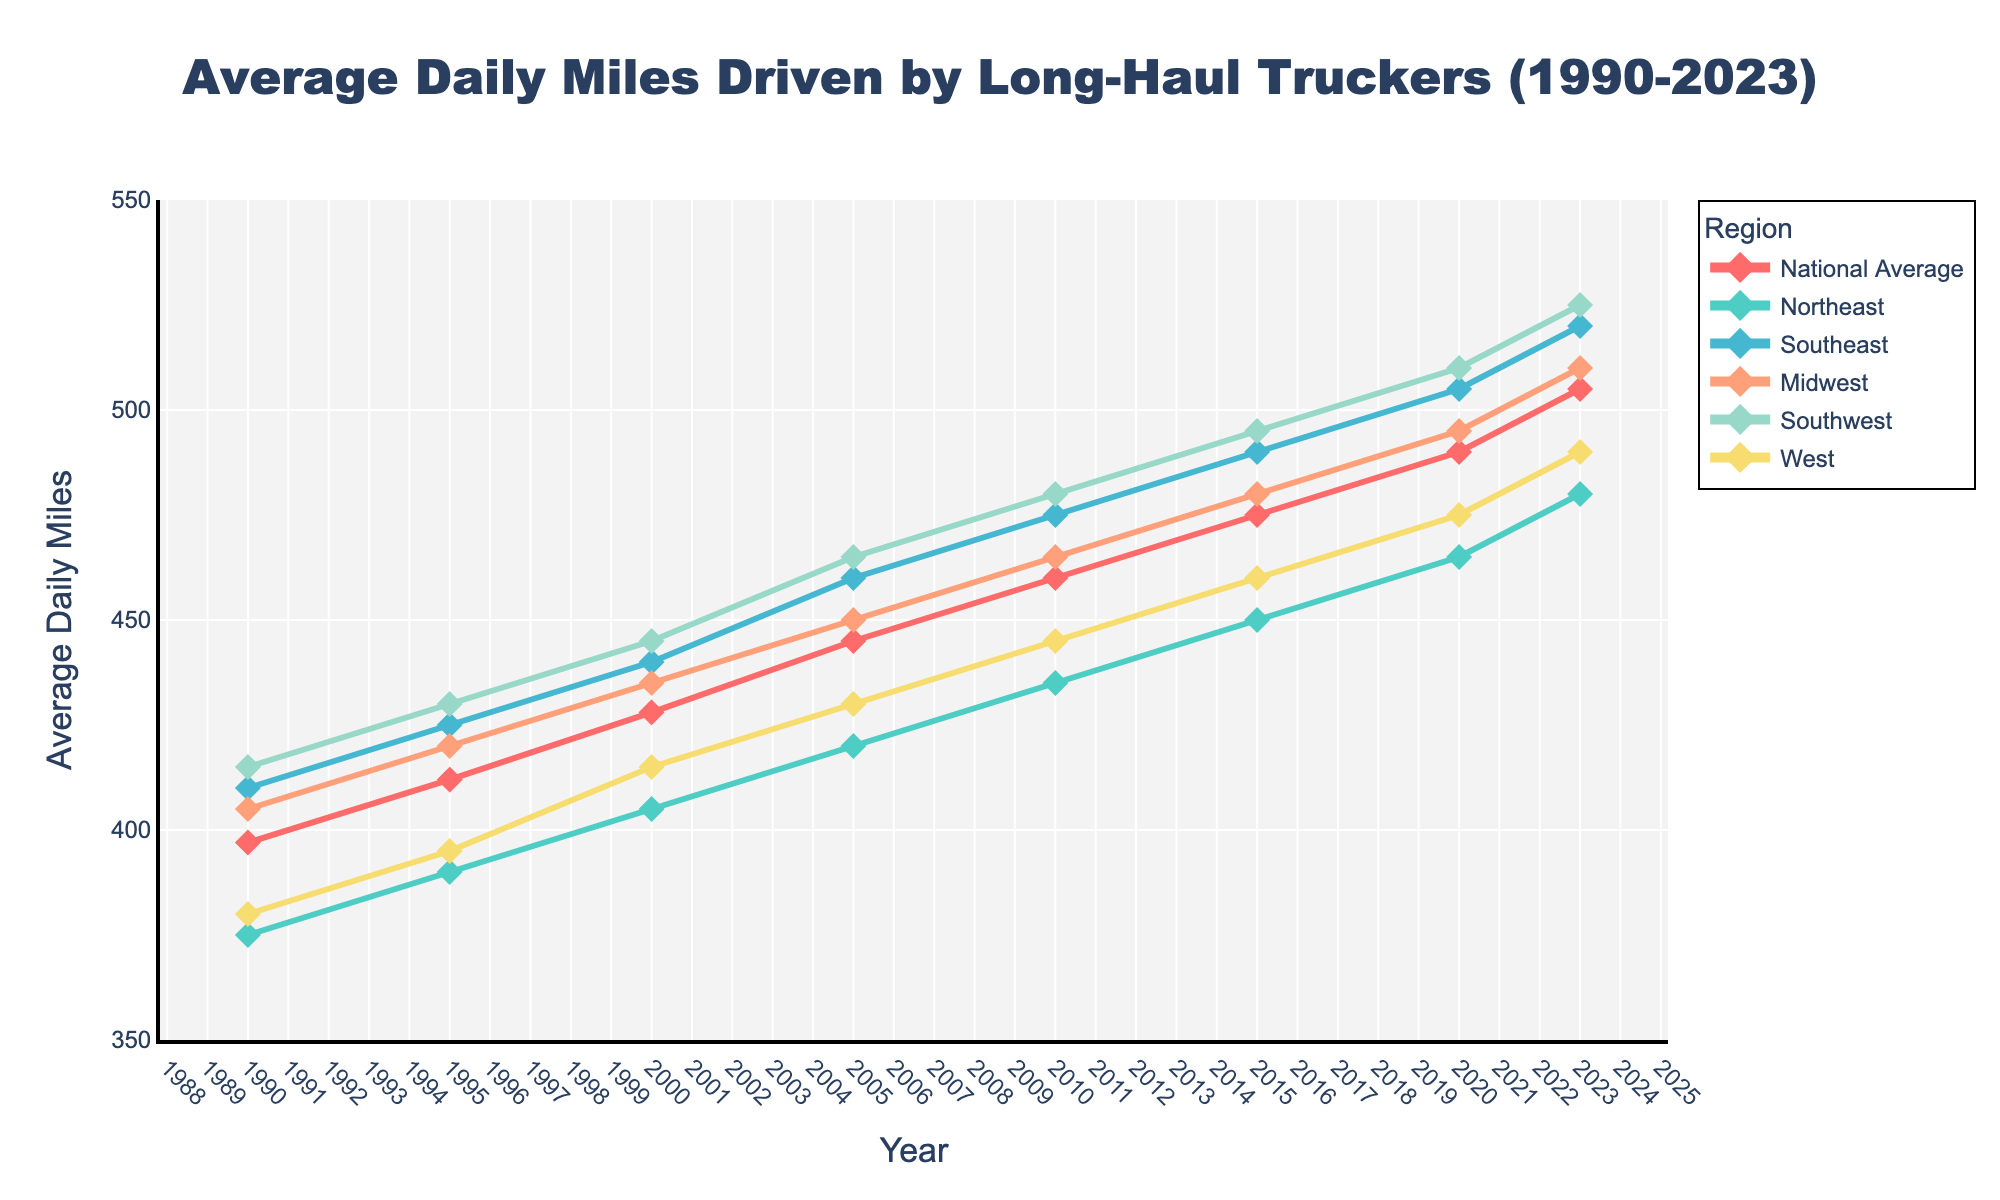Which region had the highest average daily miles in 2023? In 2023, the Southwest had the highest average daily miles as indicated by the highest point on the graph for that year.
Answer: Southwest How did the national average of daily miles driven change from 1990 to 2023? The national average of daily miles driven increased from 397 in 1990 to 505 in 2023. This can be determined by looking at the endpoints of the line representing the National Average.
Answer: Increased Which two regions had the closest average daily miles in 2010? In 2010, the Northeast and the West had the closest average daily miles, with the Northeast at 435 and the West at 445. These values can be seen by reading the points for each region in 2010.
Answer: Northeast and West What is the average increase in daily miles driven per year for the Midwest from 1990 to 2023? The increase for the Midwest from 1990 (405) to 2023 (510) is 510 - 405 = 105 miles. There are 33 years between 1990 and 2023. The average annual increase is 105/33 ≈ 3.18 miles per year.
Answer: 3.18 miles per year In which year did the Southeast first surpass 450 average daily miles? The Southeast first surpassed 450 average daily miles in 2005. This can be checked by observing that the value for the Southeast was 425 in 2000 and jumped to 460 in 2005.
Answer: 2005 Which region experienced the smallest increase in daily miles driven from 1990 to 2023? The Northeast experienced the smallest increase from 1990 (375) to 2023 (480), an increase of 480 - 375 = 105 miles. By comparing each region's increase, it's evident that the Northeast has the smallest increment.
Answer: Northeast By how much did the national average daily miles increase during the decade from 2000 to 2010? The national average increased from 428 in 2000 to 460 in 2010. The increase over this decade is 460 - 428 = 32 miles.
Answer: 32 miles Which region had the highest variability in average daily miles driven over the period of 1990 to 2023? The Southwest had the highest variability, as indicated by the largest overall range from 415 in 1990 to 525 in 2023, which is a range of 525 - 415 = 110 miles.
Answer: Southwest What is the combined average increase in daily miles driven of the Southeast and Southwest from 1990 to 2023? The Southeast increased from 410 to 520 (110 miles), and the Southwest increased from 415 to 525 (110 miles). The combined increase is 110 + 110 = 220 miles. The average increase over the period is 220/2 = 110 miles.
Answer: 110 miles Which region shows the second-largest growth in average daily miles driven from 2000 to 2020? From 2000 to 2020, both the Southwest and Southeast show the same second-largest growth of 70 miles. Southwest grew from 445 to 510 and Southeast grew from 440 to 505.
Answer: Southwest and Southeast 